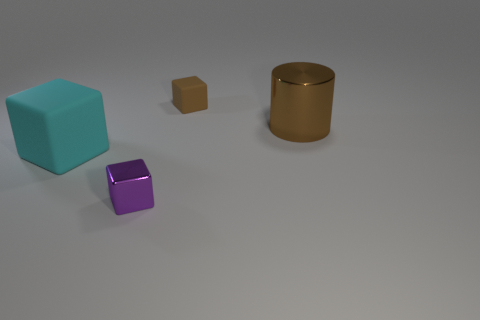Subtract all matte cubes. How many cubes are left? 1 Add 1 cylinders. How many objects exist? 5 Subtract all blocks. How many objects are left? 1 Subtract all big green cylinders. Subtract all small purple things. How many objects are left? 3 Add 4 big shiny objects. How many big shiny objects are left? 5 Add 3 tiny objects. How many tiny objects exist? 5 Subtract 0 brown spheres. How many objects are left? 4 